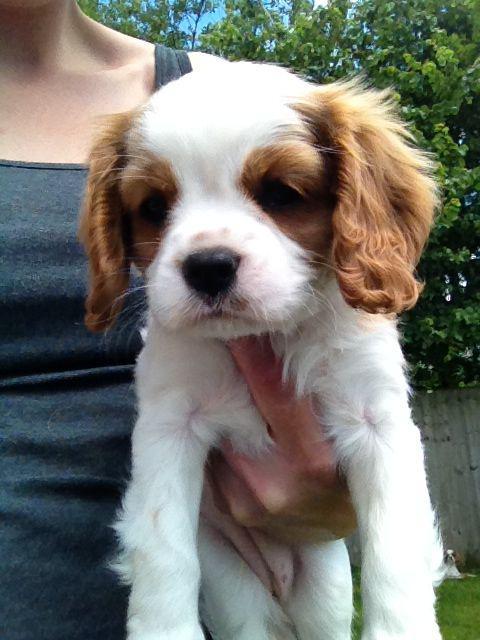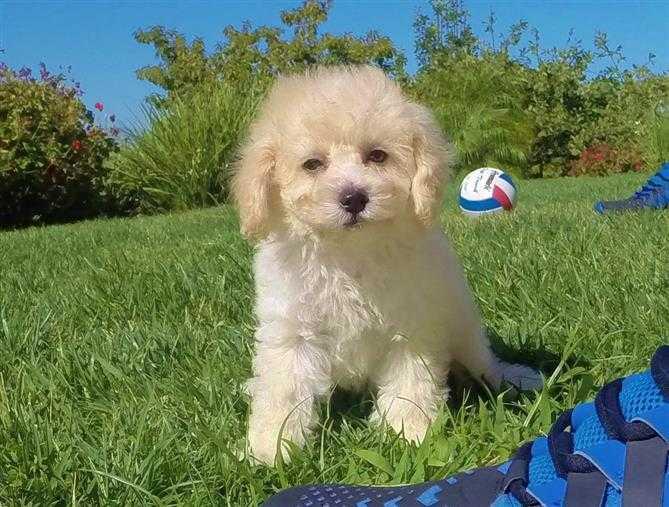The first image is the image on the left, the second image is the image on the right. Evaluate the accuracy of this statement regarding the images: "At least one of the puppies is indoors.". Is it true? Answer yes or no. No. The first image is the image on the left, the second image is the image on the right. Given the left and right images, does the statement "A brown-and-white spaniel puppy is held in a human hand outdoors." hold true? Answer yes or no. Yes. The first image is the image on the left, the second image is the image on the right. Assess this claim about the two images: "An image shows one non-standing dog posed in the grass.". Correct or not? Answer yes or no. Yes. 